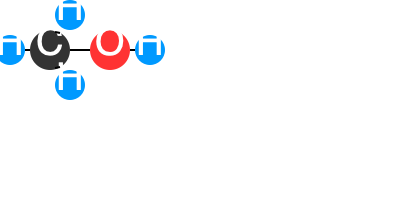How does the hydroxyl group (-OH) in ethanol's molecular structure contribute to its impact on cocktail flavors? 1. Ethanol's structure: Ethanol (C$_2$H$_5$OH) consists of an ethyl group (C$_2$H$_5$-) bonded to a hydroxyl group (-OH).

2. Hydroxyl group properties:
   a. Polarity: The -OH group is polar due to the electronegativity difference between oxygen and hydrogen.
   b. Hydrogen bonding: It can form hydrogen bonds with water and other polar molecules.

3. Impact on solubility:
   a. The polar -OH group makes ethanol soluble in water and other polar solvents.
   b. The ethyl group provides some non-polar character, allowing ethanol to dissolve non-polar flavor compounds.

4. Flavor extraction:
   a. Ethanol can extract both polar and non-polar flavor compounds from ingredients.
   b. This dual solubility enhances the overall flavor profile of cocktails.

5. Mouthfeel and perception:
   a. The -OH group interacts with taste receptors, contributing to the burning sensation of alcohol.
   b. It also affects the perceived sweetness and body of the cocktail.

6. Aroma release:
   The polarity of the -OH group influences how volatile aroma compounds are released, impacting the cocktail's bouquet.

7. Flavor stability:
   Hydrogen bonding helps stabilize certain flavor compounds, affecting how flavors evolve in the glass over time.

In summary, the hydroxyl group in ethanol's structure enables it to act as a versatile solvent, flavor extractor, and flavor modifier in cocktails, significantly impacting their overall taste, aroma, and mouthfeel.
Answer: The hydroxyl group enables ethanol to dissolve both polar and non-polar flavor compounds, extract diverse flavors, and influence taste perception, aroma release, and flavor stability in cocktails. 